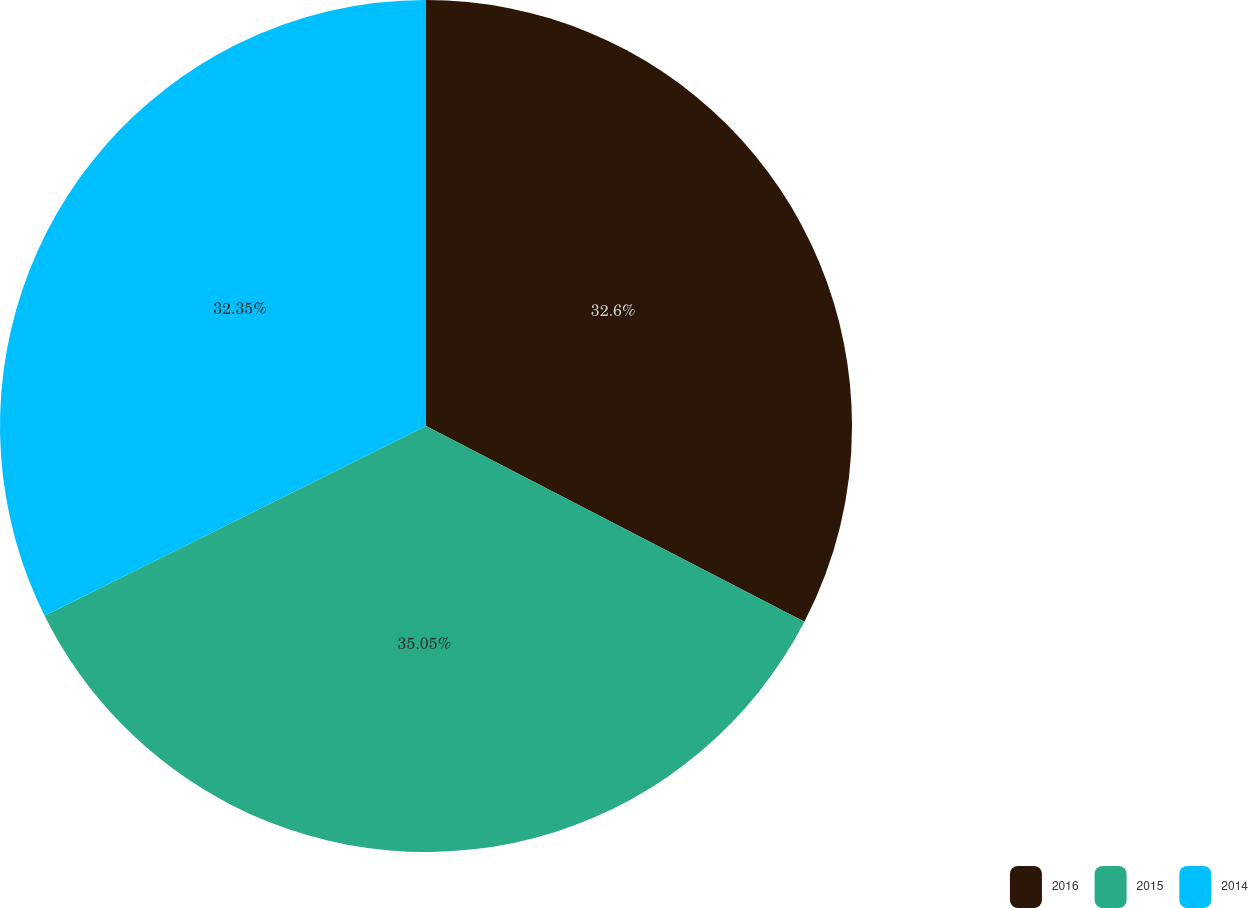<chart> <loc_0><loc_0><loc_500><loc_500><pie_chart><fcel>2016<fcel>2015<fcel>2014<nl><fcel>32.6%<fcel>35.06%<fcel>32.35%<nl></chart> 